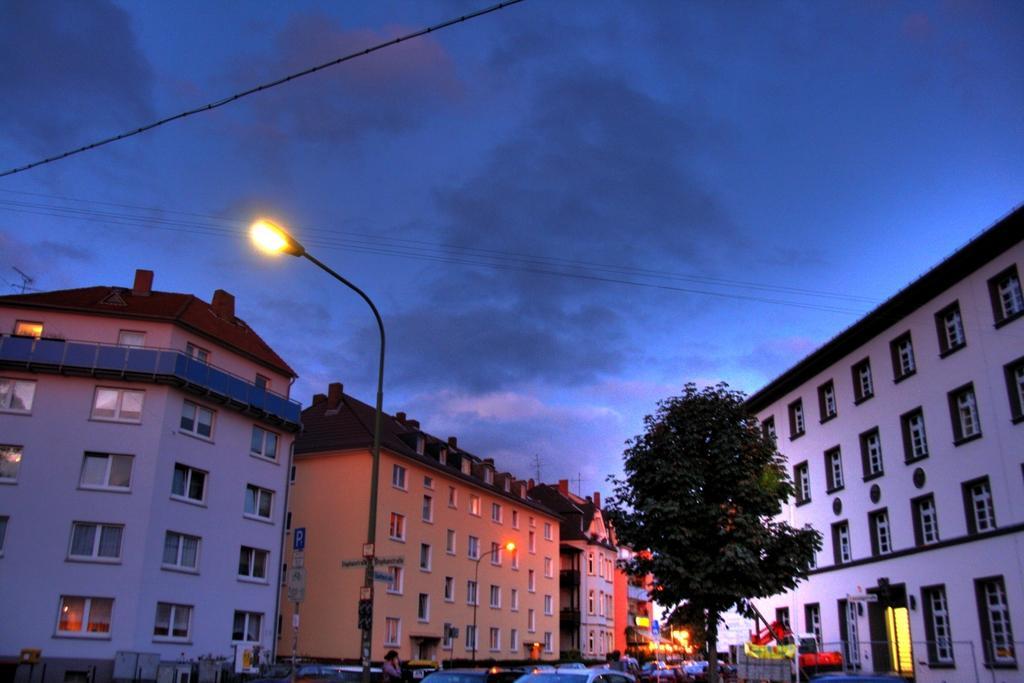Could you give a brief overview of what you see in this image? This is a picture of a city , where there are vehicles, poles, lights, buildings, and in the background there is sky. 